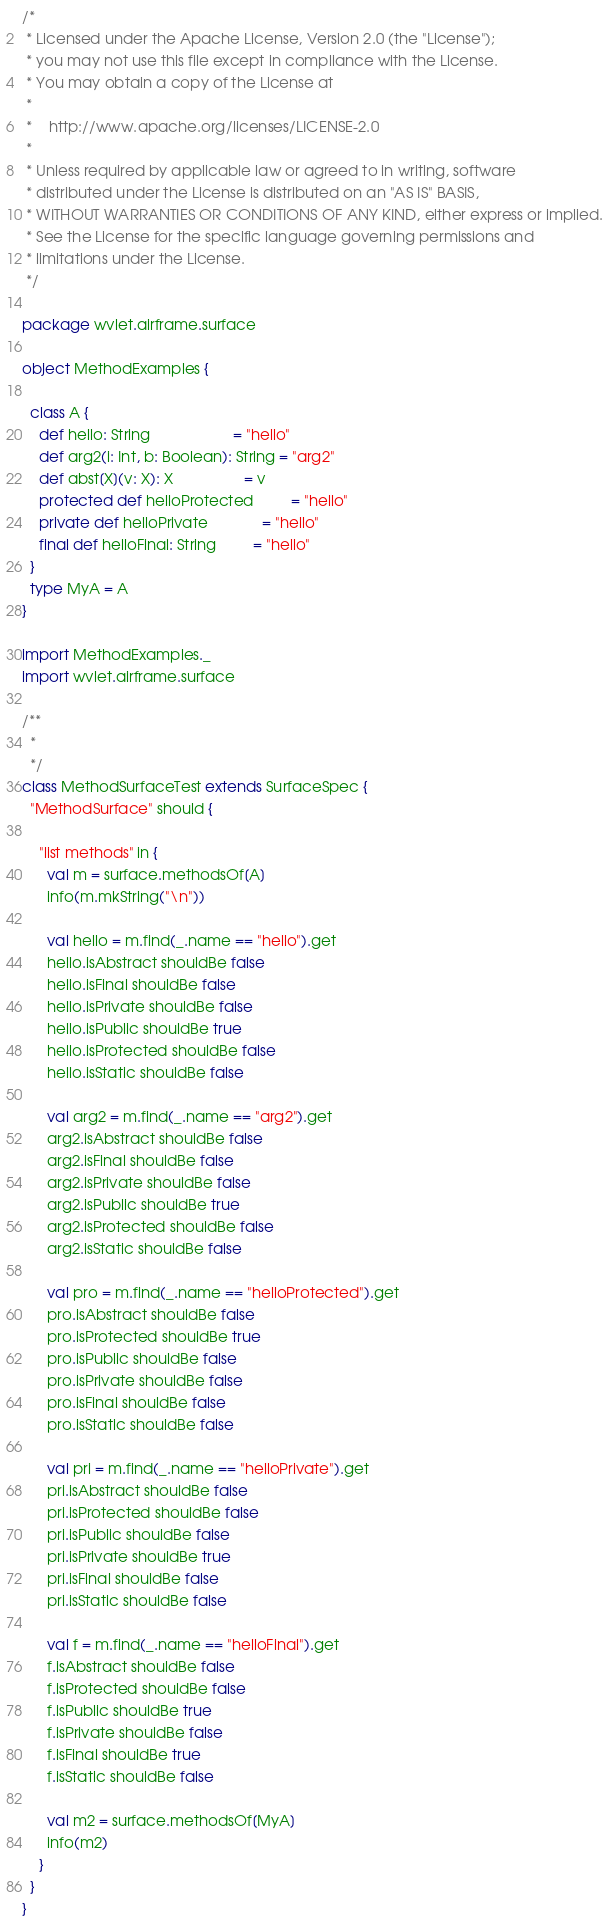Convert code to text. <code><loc_0><loc_0><loc_500><loc_500><_Scala_>/*
 * Licensed under the Apache License, Version 2.0 (the "License");
 * you may not use this file except in compliance with the License.
 * You may obtain a copy of the License at
 *
 *    http://www.apache.org/licenses/LICENSE-2.0
 *
 * Unless required by applicable law or agreed to in writing, software
 * distributed under the License is distributed on an "AS IS" BASIS,
 * WITHOUT WARRANTIES OR CONDITIONS OF ANY KIND, either express or implied.
 * See the License for the specific language governing permissions and
 * limitations under the License.
 */

package wvlet.airframe.surface

object MethodExamples {

  class A {
    def hello: String                    = "hello"
    def arg2(i: Int, b: Boolean): String = "arg2"
    def abst[X](v: X): X                 = v
    protected def helloProtected         = "hello"
    private def helloPrivate             = "hello"
    final def helloFinal: String         = "hello"
  }
  type MyA = A
}

import MethodExamples._
import wvlet.airframe.surface

/**
  *
  */
class MethodSurfaceTest extends SurfaceSpec {
  "MethodSurface" should {

    "list methods" in {
      val m = surface.methodsOf[A]
      info(m.mkString("\n"))

      val hello = m.find(_.name == "hello").get
      hello.isAbstract shouldBe false
      hello.isFinal shouldBe false
      hello.isPrivate shouldBe false
      hello.isPublic shouldBe true
      hello.isProtected shouldBe false
      hello.isStatic shouldBe false

      val arg2 = m.find(_.name == "arg2").get
      arg2.isAbstract shouldBe false
      arg2.isFinal shouldBe false
      arg2.isPrivate shouldBe false
      arg2.isPublic shouldBe true
      arg2.isProtected shouldBe false
      arg2.isStatic shouldBe false

      val pro = m.find(_.name == "helloProtected").get
      pro.isAbstract shouldBe false
      pro.isProtected shouldBe true
      pro.isPublic shouldBe false
      pro.isPrivate shouldBe false
      pro.isFinal shouldBe false
      pro.isStatic shouldBe false

      val pri = m.find(_.name == "helloPrivate").get
      pri.isAbstract shouldBe false
      pri.isProtected shouldBe false
      pri.isPublic shouldBe false
      pri.isPrivate shouldBe true
      pri.isFinal shouldBe false
      pri.isStatic shouldBe false

      val f = m.find(_.name == "helloFinal").get
      f.isAbstract shouldBe false
      f.isProtected shouldBe false
      f.isPublic shouldBe true
      f.isPrivate shouldBe false
      f.isFinal shouldBe true
      f.isStatic shouldBe false

      val m2 = surface.methodsOf[MyA]
      info(m2)
    }
  }
}
</code> 